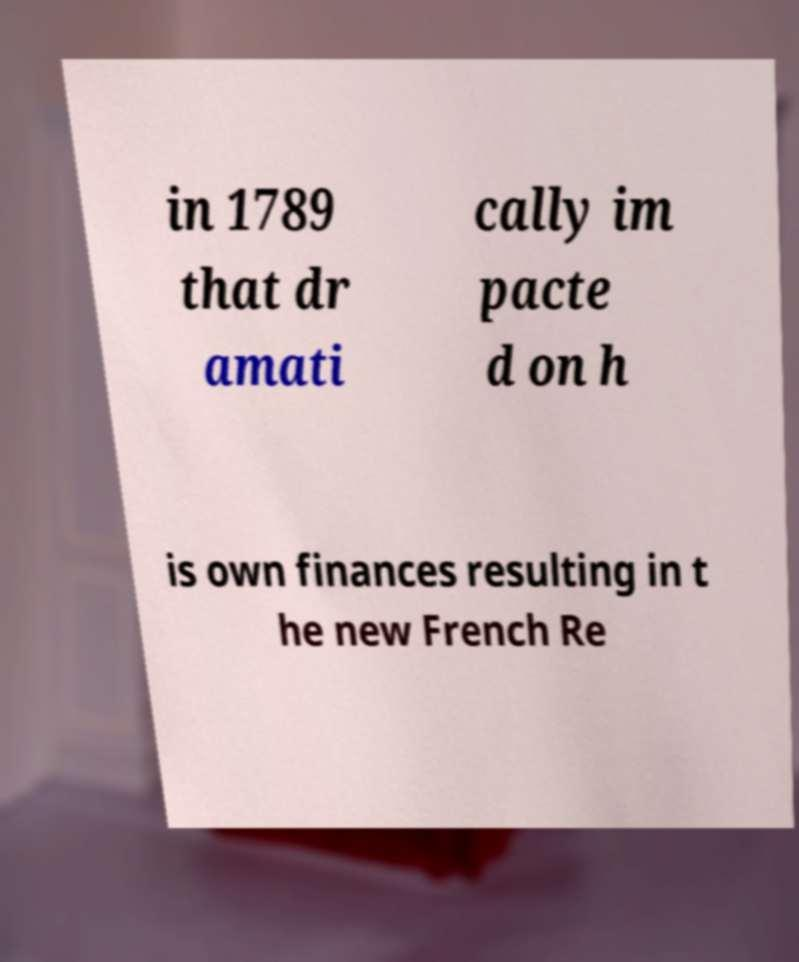I need the written content from this picture converted into text. Can you do that? in 1789 that dr amati cally im pacte d on h is own finances resulting in t he new French Re 